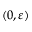<formula> <loc_0><loc_0><loc_500><loc_500>( 0 , \varepsilon )</formula> 